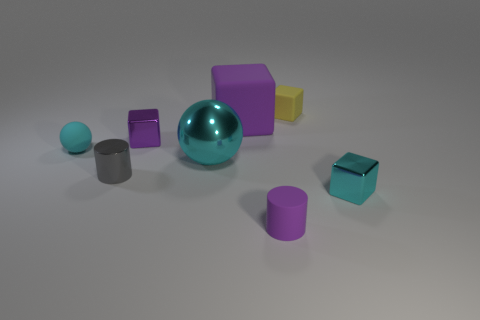The cyan metal thing that is to the left of the cyan cube has what shape?
Keep it short and to the point. Sphere. The other block that is the same material as the yellow cube is what size?
Provide a succinct answer. Large. How many small cyan things have the same shape as the big cyan thing?
Offer a terse response. 1. There is a metal object that is to the right of the tiny yellow rubber cube; is its color the same as the small ball?
Keep it short and to the point. Yes. How many cyan matte balls are on the right side of the matte cube behind the purple matte object that is behind the purple metal thing?
Ensure brevity in your answer.  0. What number of small things are to the left of the small yellow rubber cube and behind the tiny purple rubber cylinder?
Keep it short and to the point. 3. What shape is the small rubber thing that is the same color as the metal ball?
Make the answer very short. Sphere. Is there anything else that is the same material as the tiny gray object?
Make the answer very short. Yes. Is the small purple block made of the same material as the large cyan thing?
Offer a terse response. Yes. The cyan object that is right of the rubber thing that is in front of the cube in front of the big cyan ball is what shape?
Make the answer very short. Cube. 